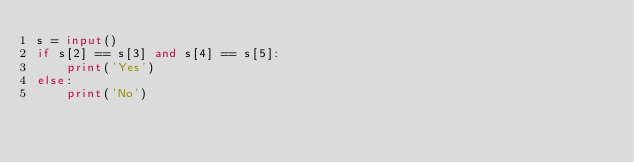<code> <loc_0><loc_0><loc_500><loc_500><_Python_>s = input()
if s[2] == s[3] and s[4] == s[5]:
    print('Yes')
else:
    print('No')</code> 